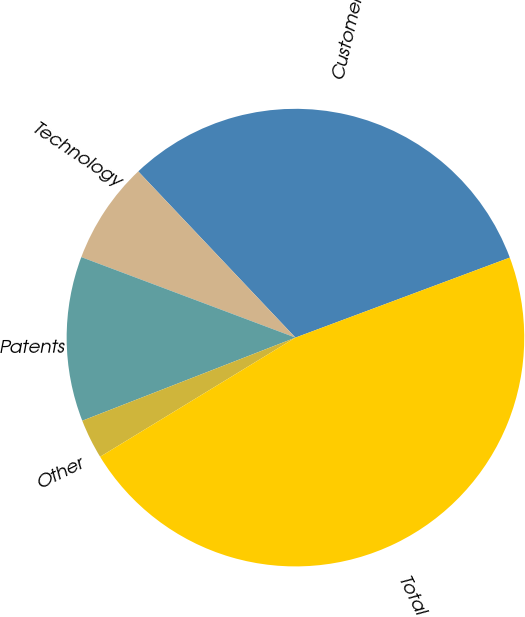Convert chart. <chart><loc_0><loc_0><loc_500><loc_500><pie_chart><fcel>Customer-related<fcel>Technology<fcel>Patents<fcel>Other<fcel>Total<nl><fcel>31.37%<fcel>7.22%<fcel>11.64%<fcel>2.8%<fcel>46.97%<nl></chart> 